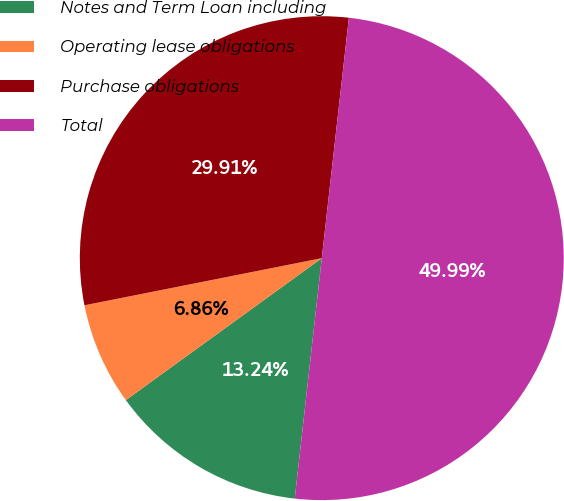Convert chart to OTSL. <chart><loc_0><loc_0><loc_500><loc_500><pie_chart><fcel>Notes and Term Loan including<fcel>Operating lease obligations<fcel>Purchase obligations<fcel>Total<nl><fcel>13.24%<fcel>6.86%<fcel>29.91%<fcel>50.0%<nl></chart> 